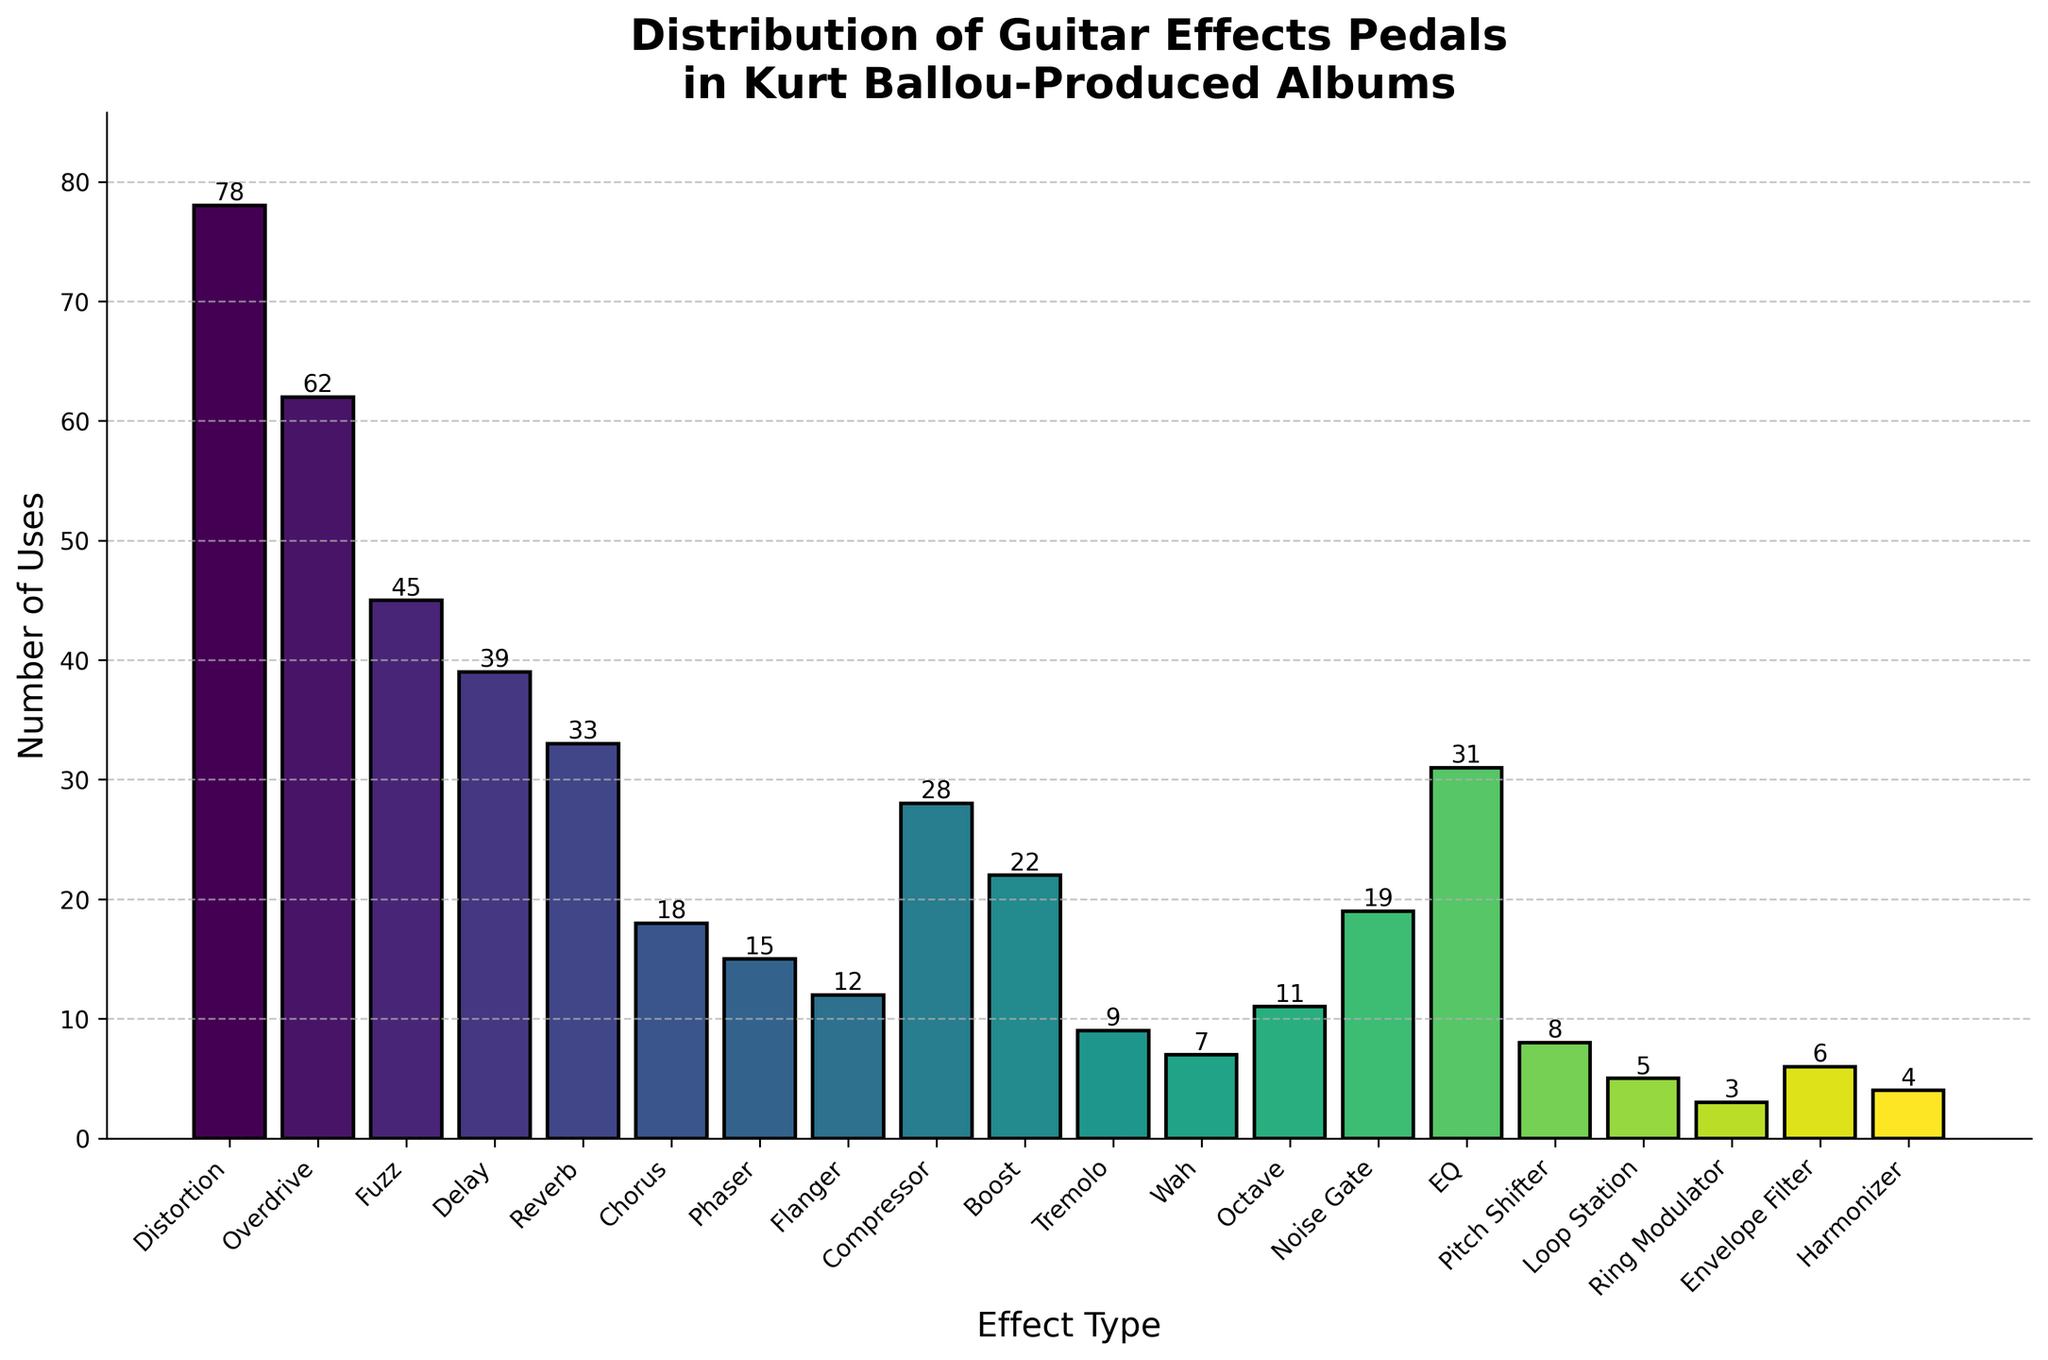Which effect type is used the most frequently? The highest bar in the chart represents the effect type "Distortion" with 78 uses.
Answer: Distortion What's the combined number of uses for "Overdrive" and "Fuzz" effects? Add the number of uses for "Overdrive" (62) and "Fuzz" (45): 62 + 45 = 107
Answer: 107 Which effect type is just as frequently used as "Compressor"? The "EQ" effect type shares the same height in the bar chart, with 31 uses, as "Compressor".
Answer: EQ Are "Octave" effects used more frequently or less frequently than "Phaser" effects? Compare the heights of the bars for "Octave" (11 uses) and "Phaser" (15 uses). "Octave" has fewer uses.
Answer: Less frequently How many more times is "Distortion" used compared to "Reverb"? Calculate the difference between the uses of "Distortion" (78) and "Reverb" (33): 78 - 33 = 45
Answer: 45 What is the average number of uses for "Delay", "Reverb", and "Chorus" effects? Add the number of uses for "Delay" (39), "Reverb" (33), and "Chorus" (18) and divide by 3: (39 + 33 + 18) / 3 = 30
Answer: 30 Is the number of "Boost" effects used greater than, less than, or equal to the number of "Noise Gate" effects used? Compare the heights of the bars for "Boost" (22 usages) and "Noise Gate" (19 usages). "Boost" has greater usage.
Answer: Greater than Which of the effect types has the second-highest frequency of usage? The "Overdrive" effect type has the second-highest frequency with 62 uses, as indicated by the second-tallest bar in the chart.
Answer: Overdrive What is the total number of uses for "Wah", "Octave", and "Pitch Shifter" effects combined? Add the number of uses for "Wah" (7), "Octave" (11), and "Pitch Shifter" (8): 7 + 11 + 8 = 26
Answer: 26 What colors are used for the tallest and shortest bars in the chart? The tallest bar, representing "Distortion", uses a color from the violet end of the spectrum, while the shortest bar, representing "Ring Modulator", uses a color from the yellow to green spectrum based on the gradient used.
Answer: Violet and Yellow/Green 